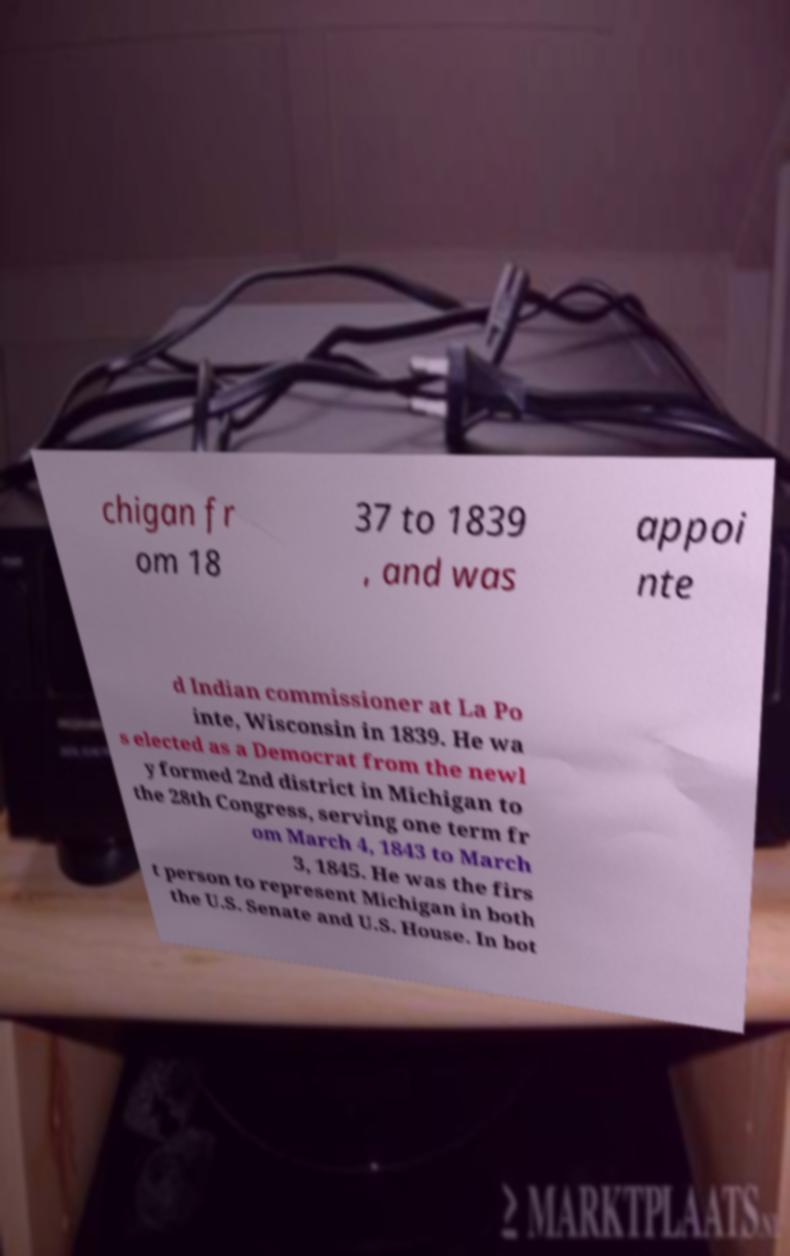Can you read and provide the text displayed in the image?This photo seems to have some interesting text. Can you extract and type it out for me? chigan fr om 18 37 to 1839 , and was appoi nte d Indian commissioner at La Po inte, Wisconsin in 1839. He wa s elected as a Democrat from the newl y formed 2nd district in Michigan to the 28th Congress, serving one term fr om March 4, 1843 to March 3, 1845. He was the firs t person to represent Michigan in both the U.S. Senate and U.S. House. In bot 